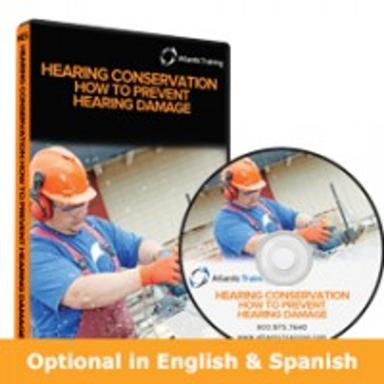What type of personal protective equipment does the worker on the DVD cover appear to be using? The worker on the DVD cover is using earmuffs, which are essential for hearing protection in environments with high noise levels. These earmuffs help prevent hearing damage, which aligns with the DVD's educational content. 